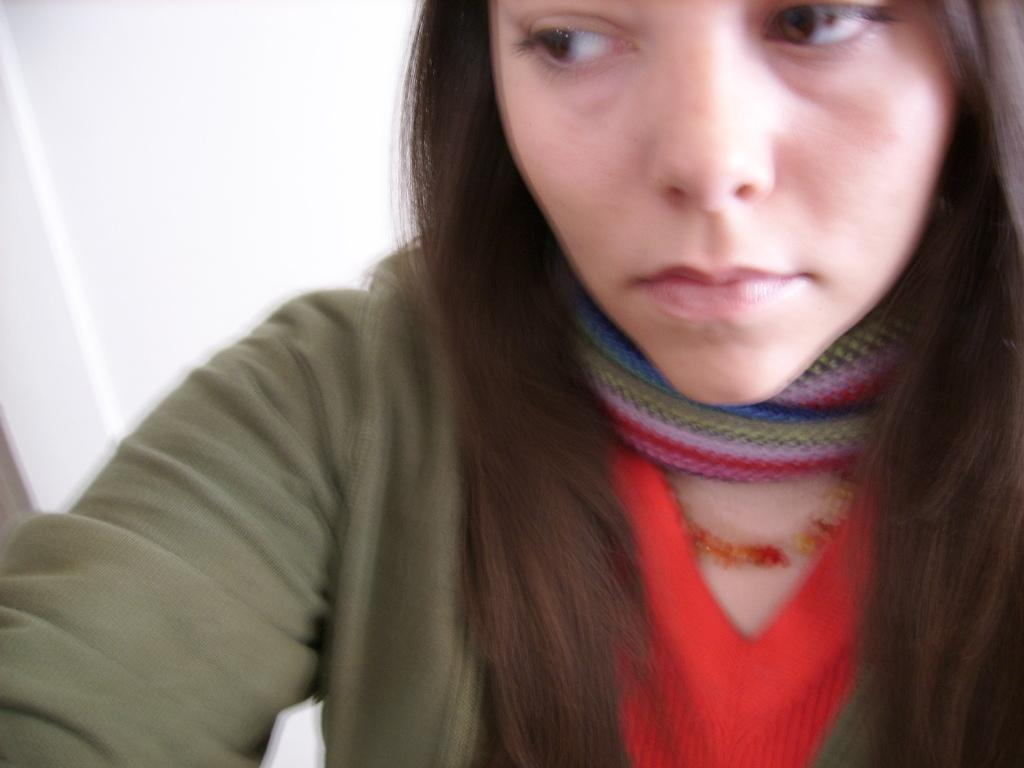Who is the main subject in the image? There is a girl in the image. Where is the girl located in the image? The girl is on the right side of the image. What type of net is being used by the girl in the image? There is no net present in the image; it only features a girl on the right side. 